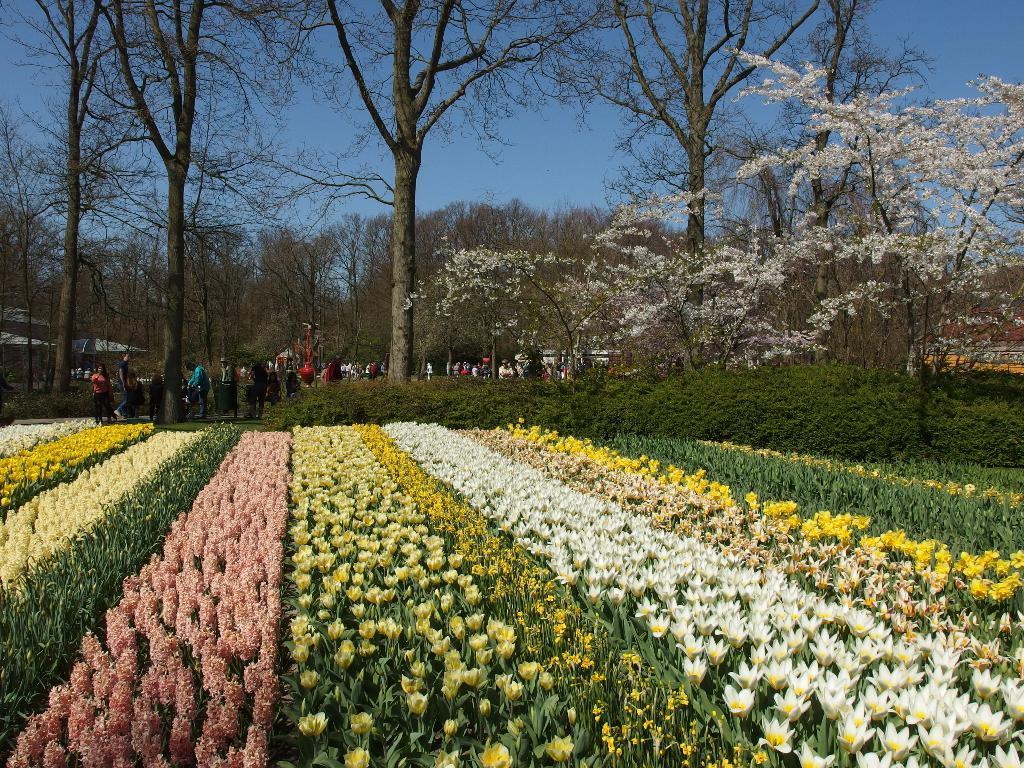Could you give a brief overview of what you see in this image? In this image we can see a group of plants with flowers. We can also see some people standing, a group of trees, some tents and the sky which looks cloudy. 